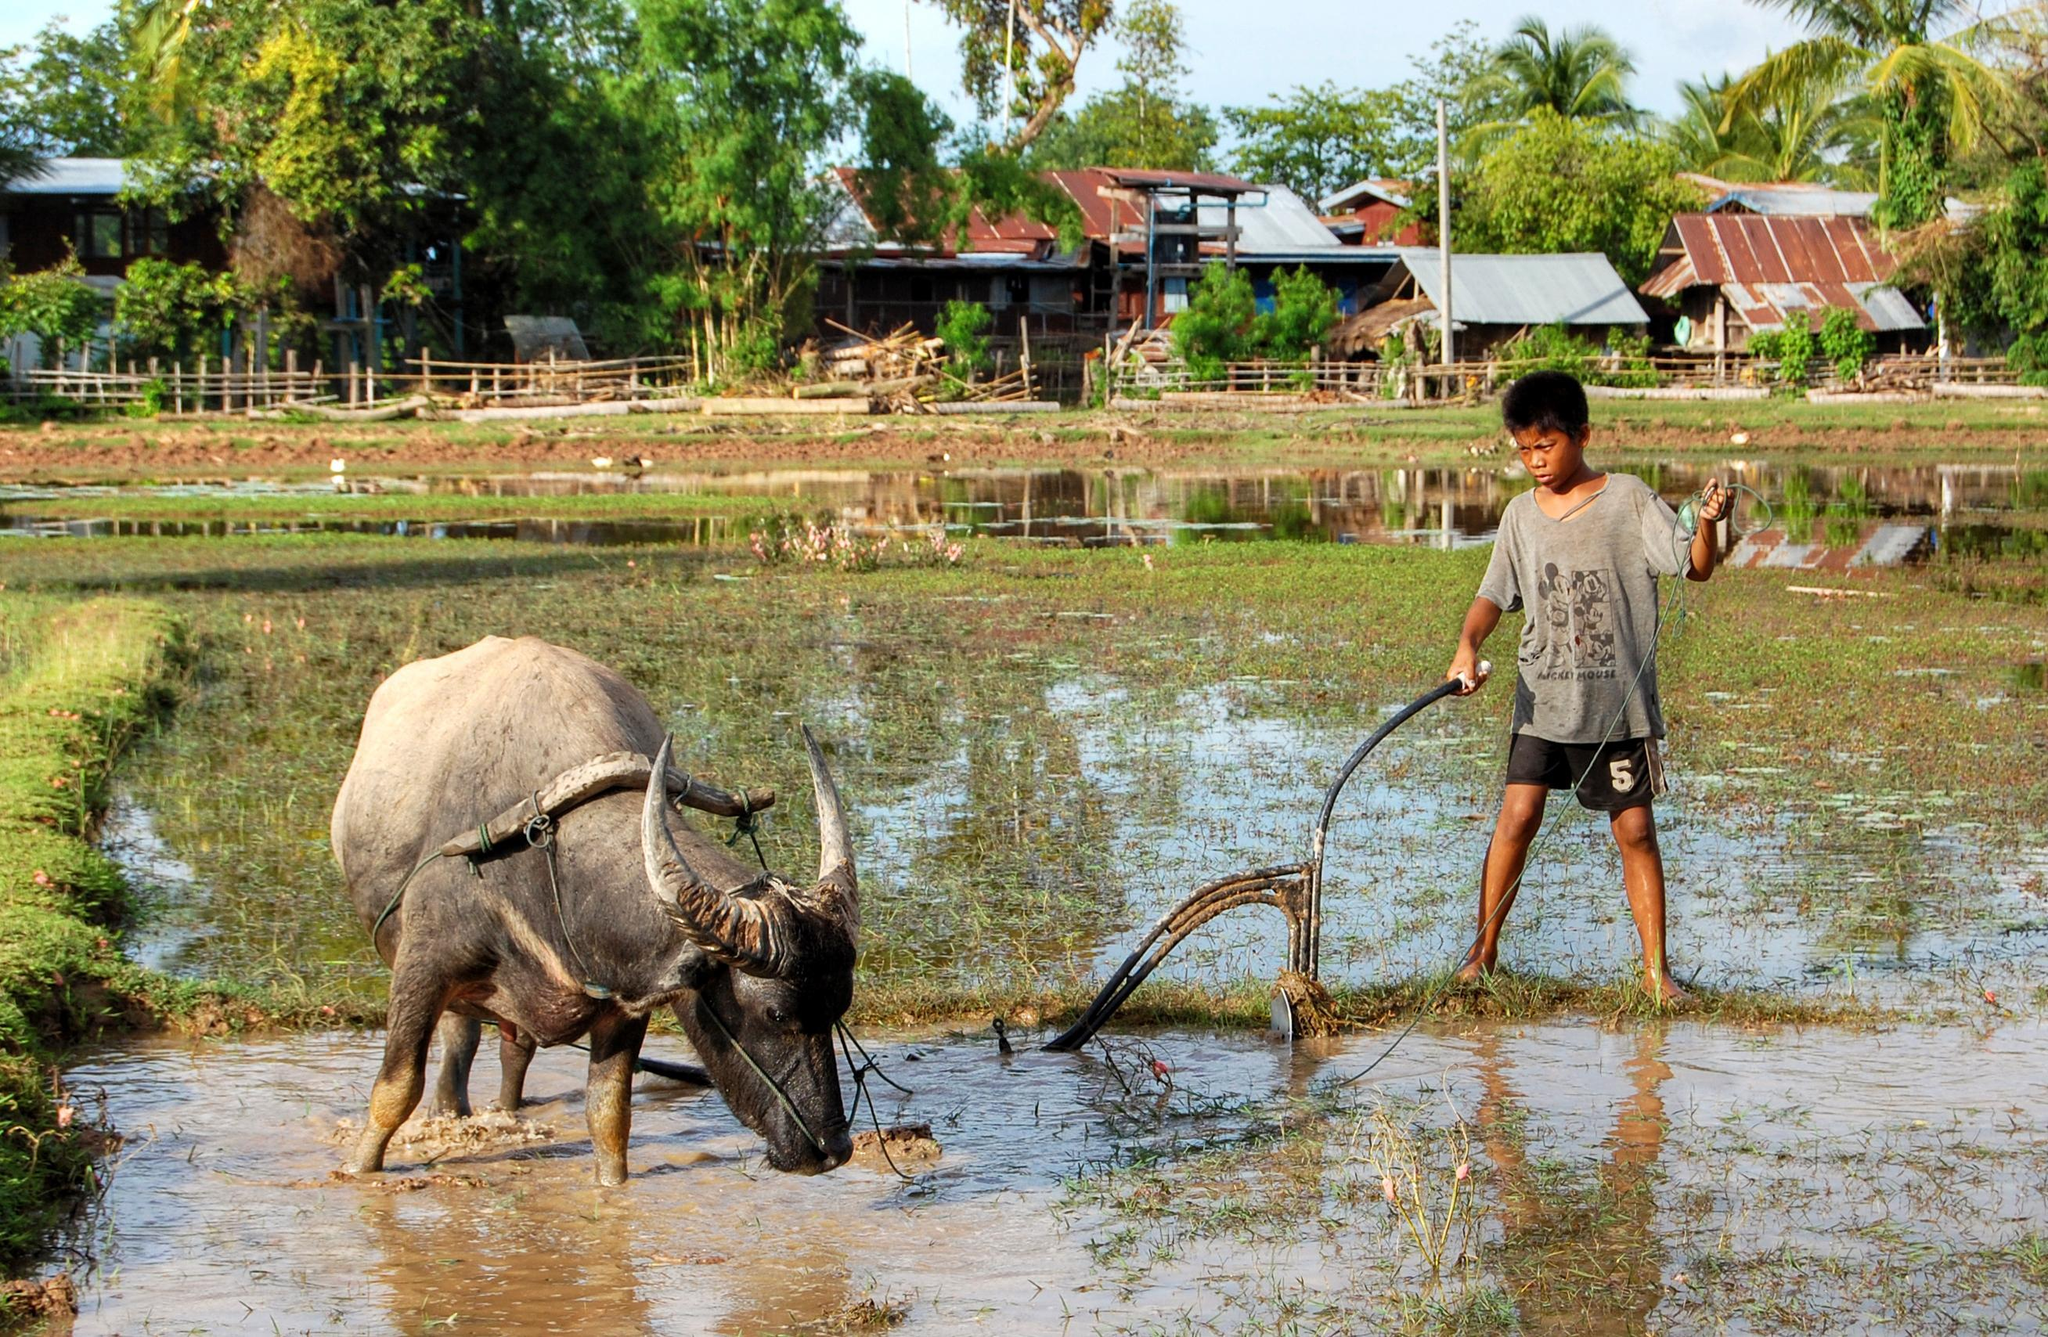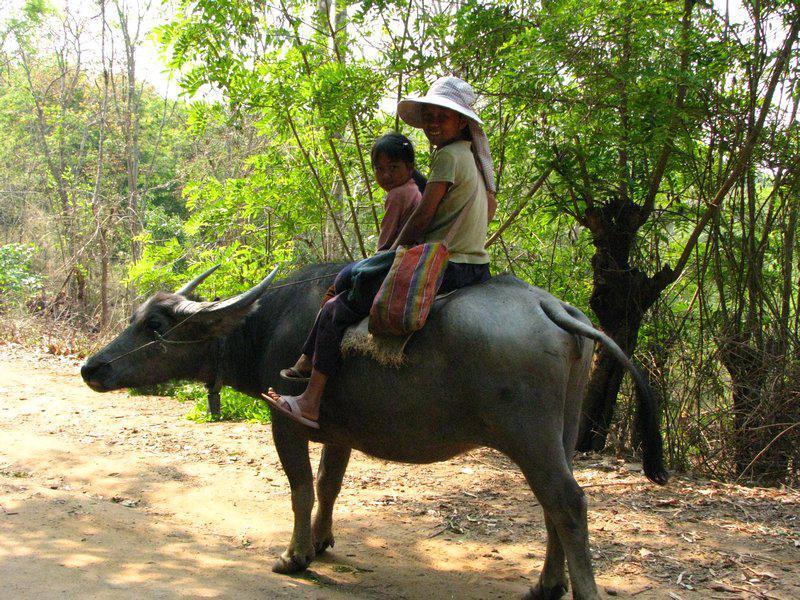The first image is the image on the left, the second image is the image on the right. Evaluate the accuracy of this statement regarding the images: "An ox is being ridden by at least one picture in all images.". Is it true? Answer yes or no. No. The first image is the image on the left, the second image is the image on the right. Examine the images to the left and right. Is the description "At least two people are riding together on the back of one horned animal in a scene." accurate? Answer yes or no. Yes. 